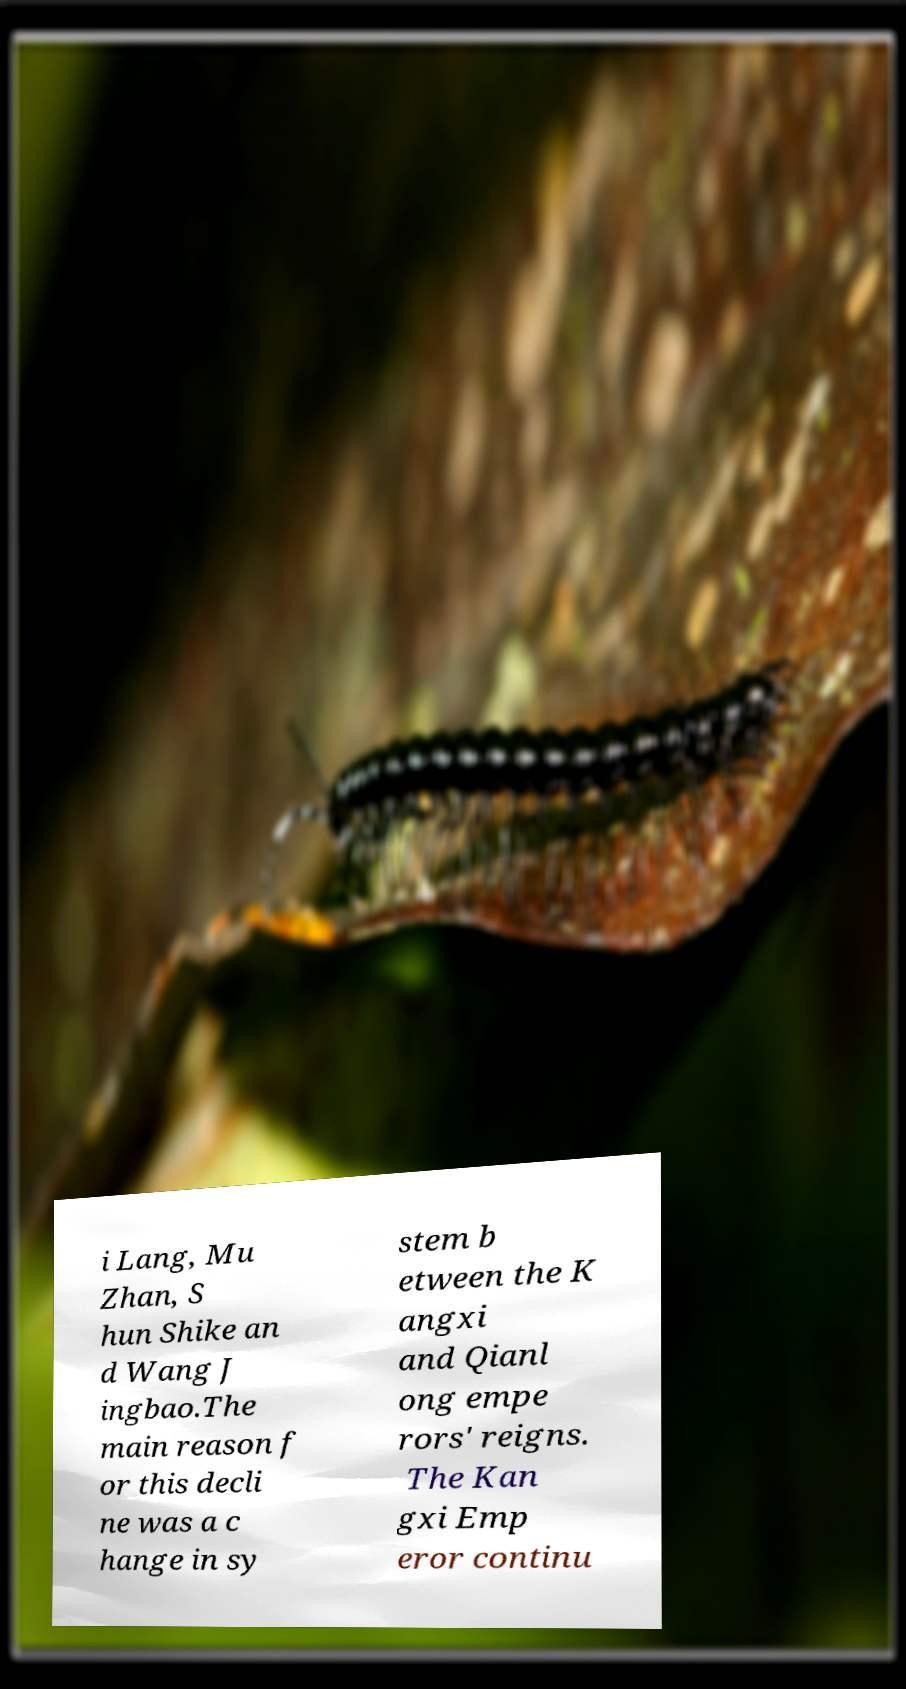Can you accurately transcribe the text from the provided image for me? i Lang, Mu Zhan, S hun Shike an d Wang J ingbao.The main reason f or this decli ne was a c hange in sy stem b etween the K angxi and Qianl ong empe rors' reigns. The Kan gxi Emp eror continu 